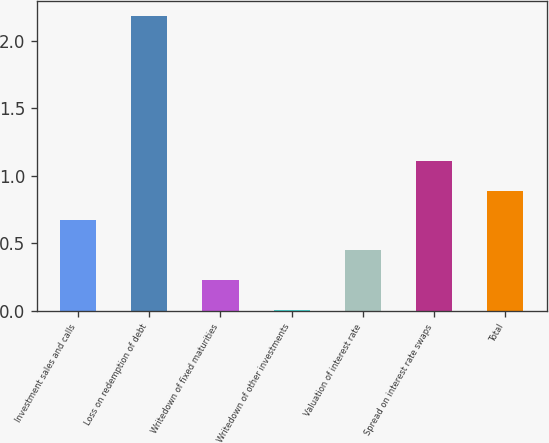Convert chart. <chart><loc_0><loc_0><loc_500><loc_500><bar_chart><fcel>Investment sales and calls<fcel>Loss on redemption of debt<fcel>Writedown of fixed maturities<fcel>Writedown of other investments<fcel>Valuation of interest rate<fcel>Spread on interest rate swaps<fcel>Total<nl><fcel>0.67<fcel>2.18<fcel>0.23<fcel>0.01<fcel>0.45<fcel>1.11<fcel>0.89<nl></chart> 